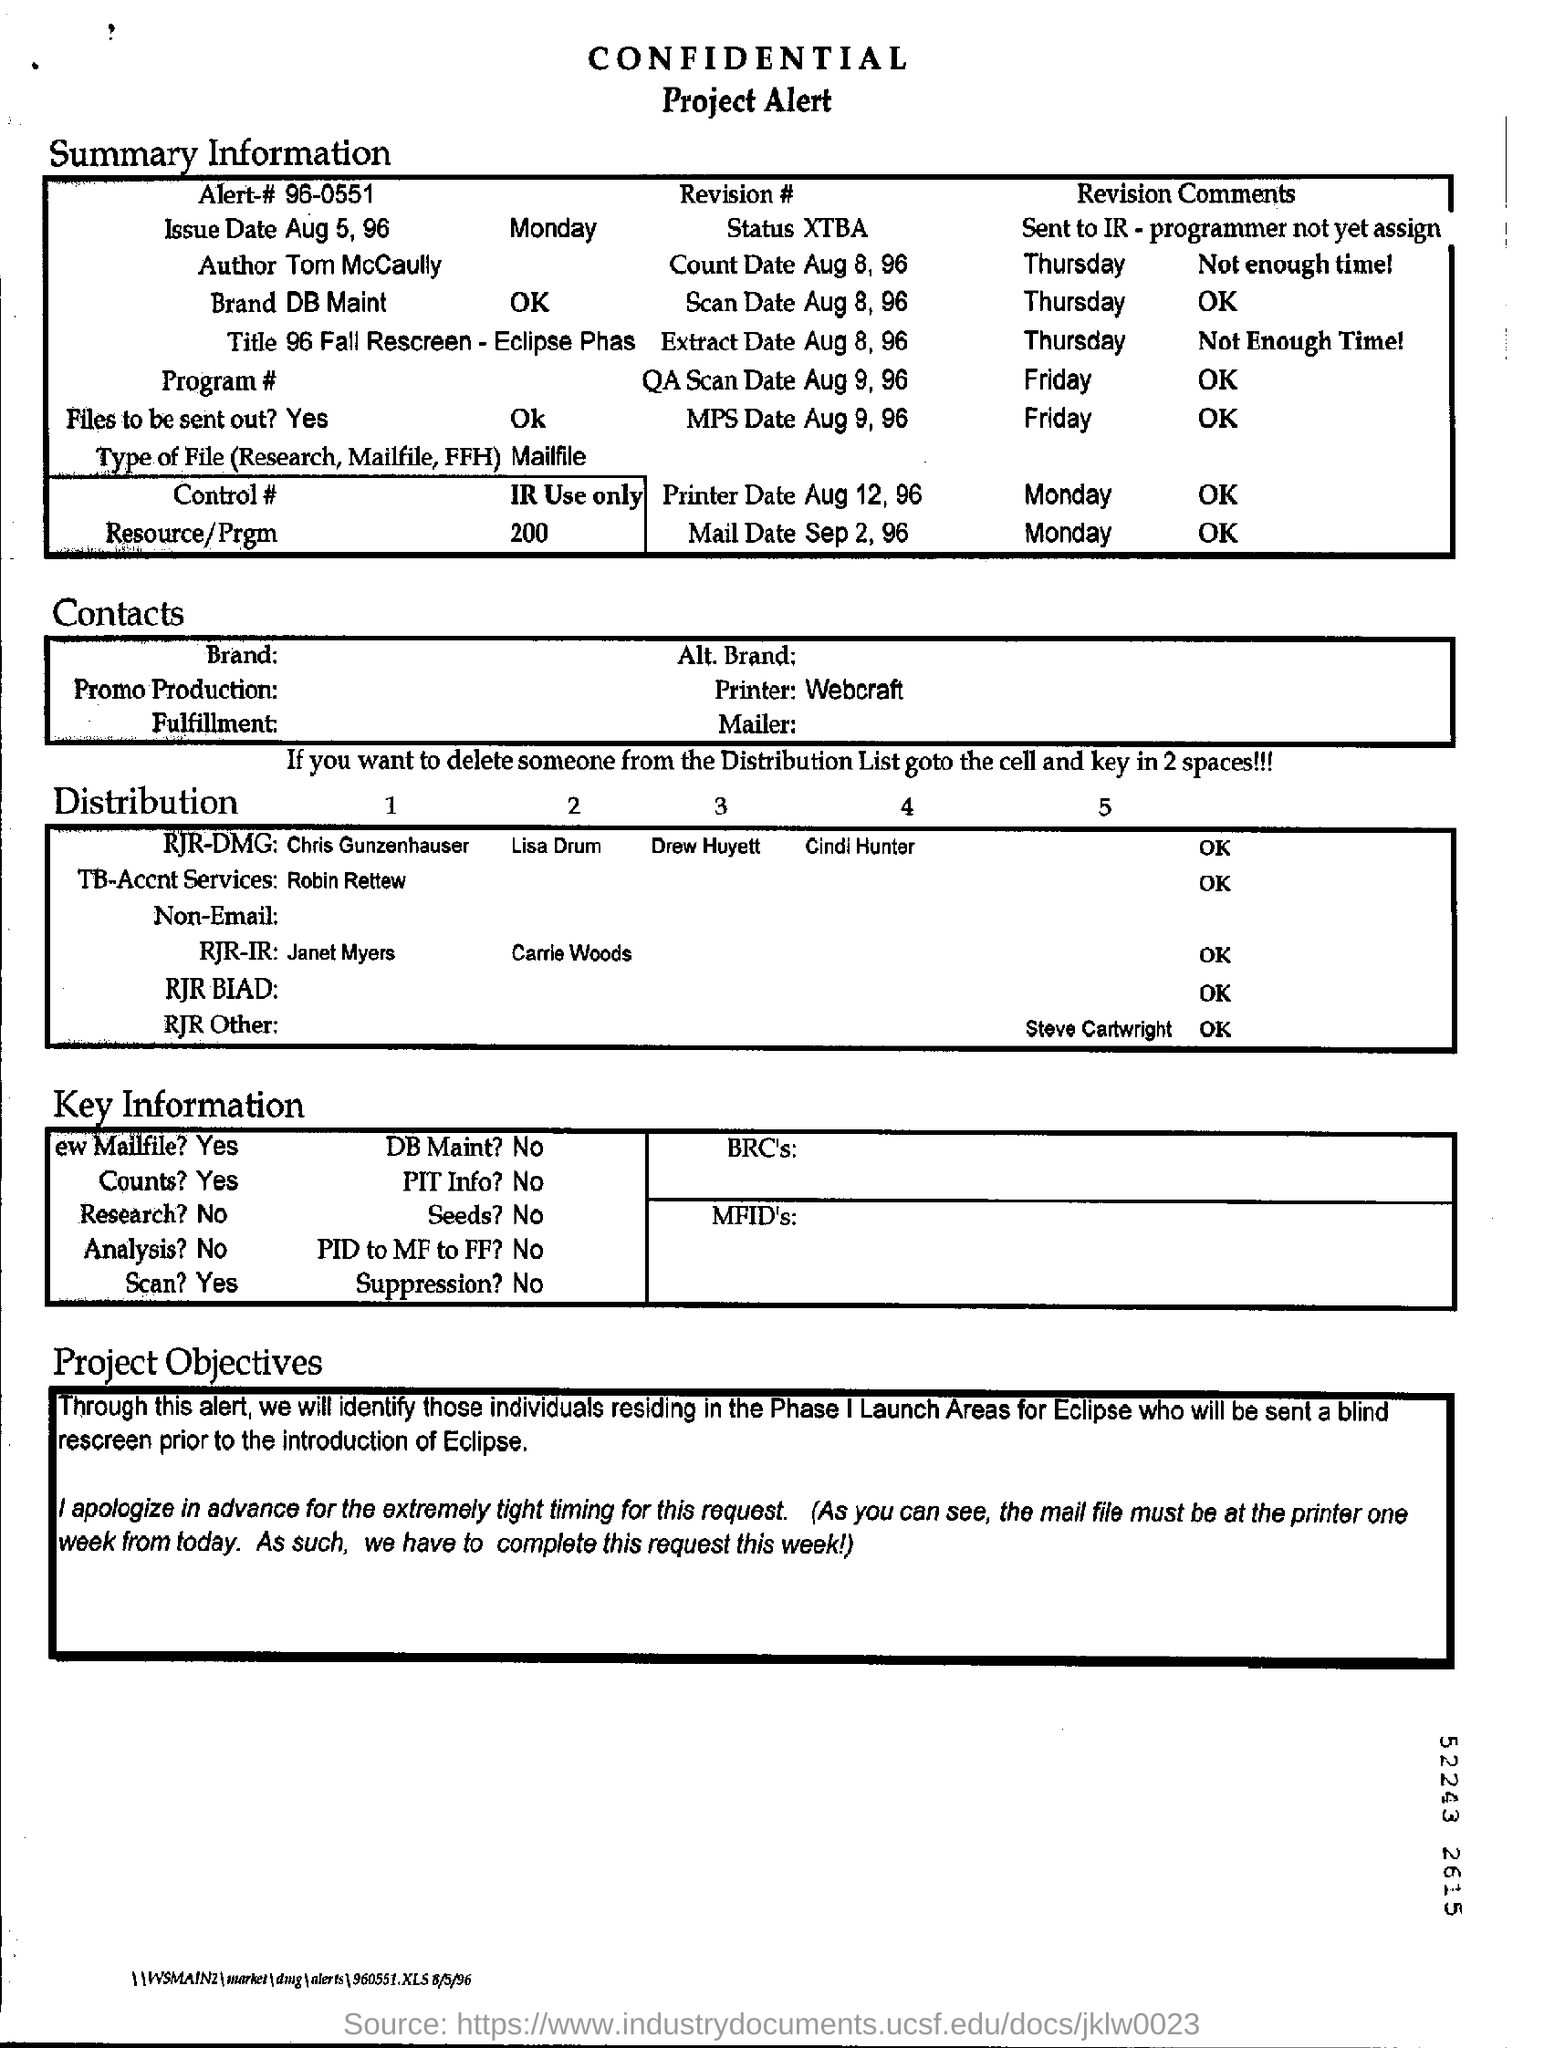What is the Alert #?
Make the answer very short. 96-0551. When is the Issue date?
Ensure brevity in your answer.  Aug 5, 96. What is the Count date?
Your answer should be compact. Aug 8, 96. What is the Printer Date?
Keep it short and to the point. Aug 12, 96. Who is the author?
Offer a terse response. Tom McCaully. What is the QA Scan date?
Your answer should be very brief. Aug 9, 96. What is the MPS date?
Your answer should be very brief. Aug 9, 96. What is the Mail date?
Your answer should be very brief. Sep 2, 96. What is the status?
Your response must be concise. XTBA. 